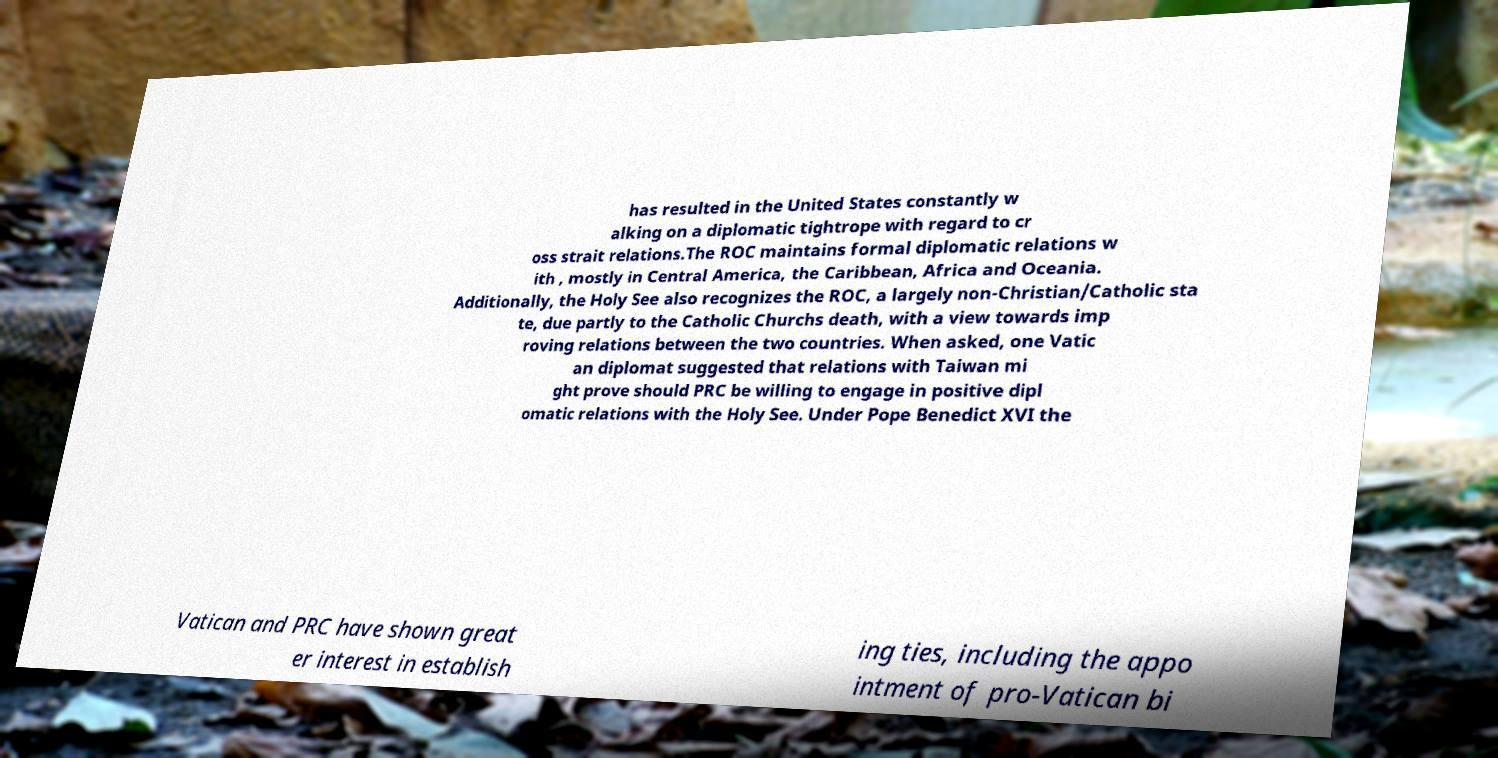For documentation purposes, I need the text within this image transcribed. Could you provide that? has resulted in the United States constantly w alking on a diplomatic tightrope with regard to cr oss strait relations.The ROC maintains formal diplomatic relations w ith , mostly in Central America, the Caribbean, Africa and Oceania. Additionally, the Holy See also recognizes the ROC, a largely non-Christian/Catholic sta te, due partly to the Catholic Churchs death, with a view towards imp roving relations between the two countries. When asked, one Vatic an diplomat suggested that relations with Taiwan mi ght prove should PRC be willing to engage in positive dipl omatic relations with the Holy See. Under Pope Benedict XVI the Vatican and PRC have shown great er interest in establish ing ties, including the appo intment of pro-Vatican bi 